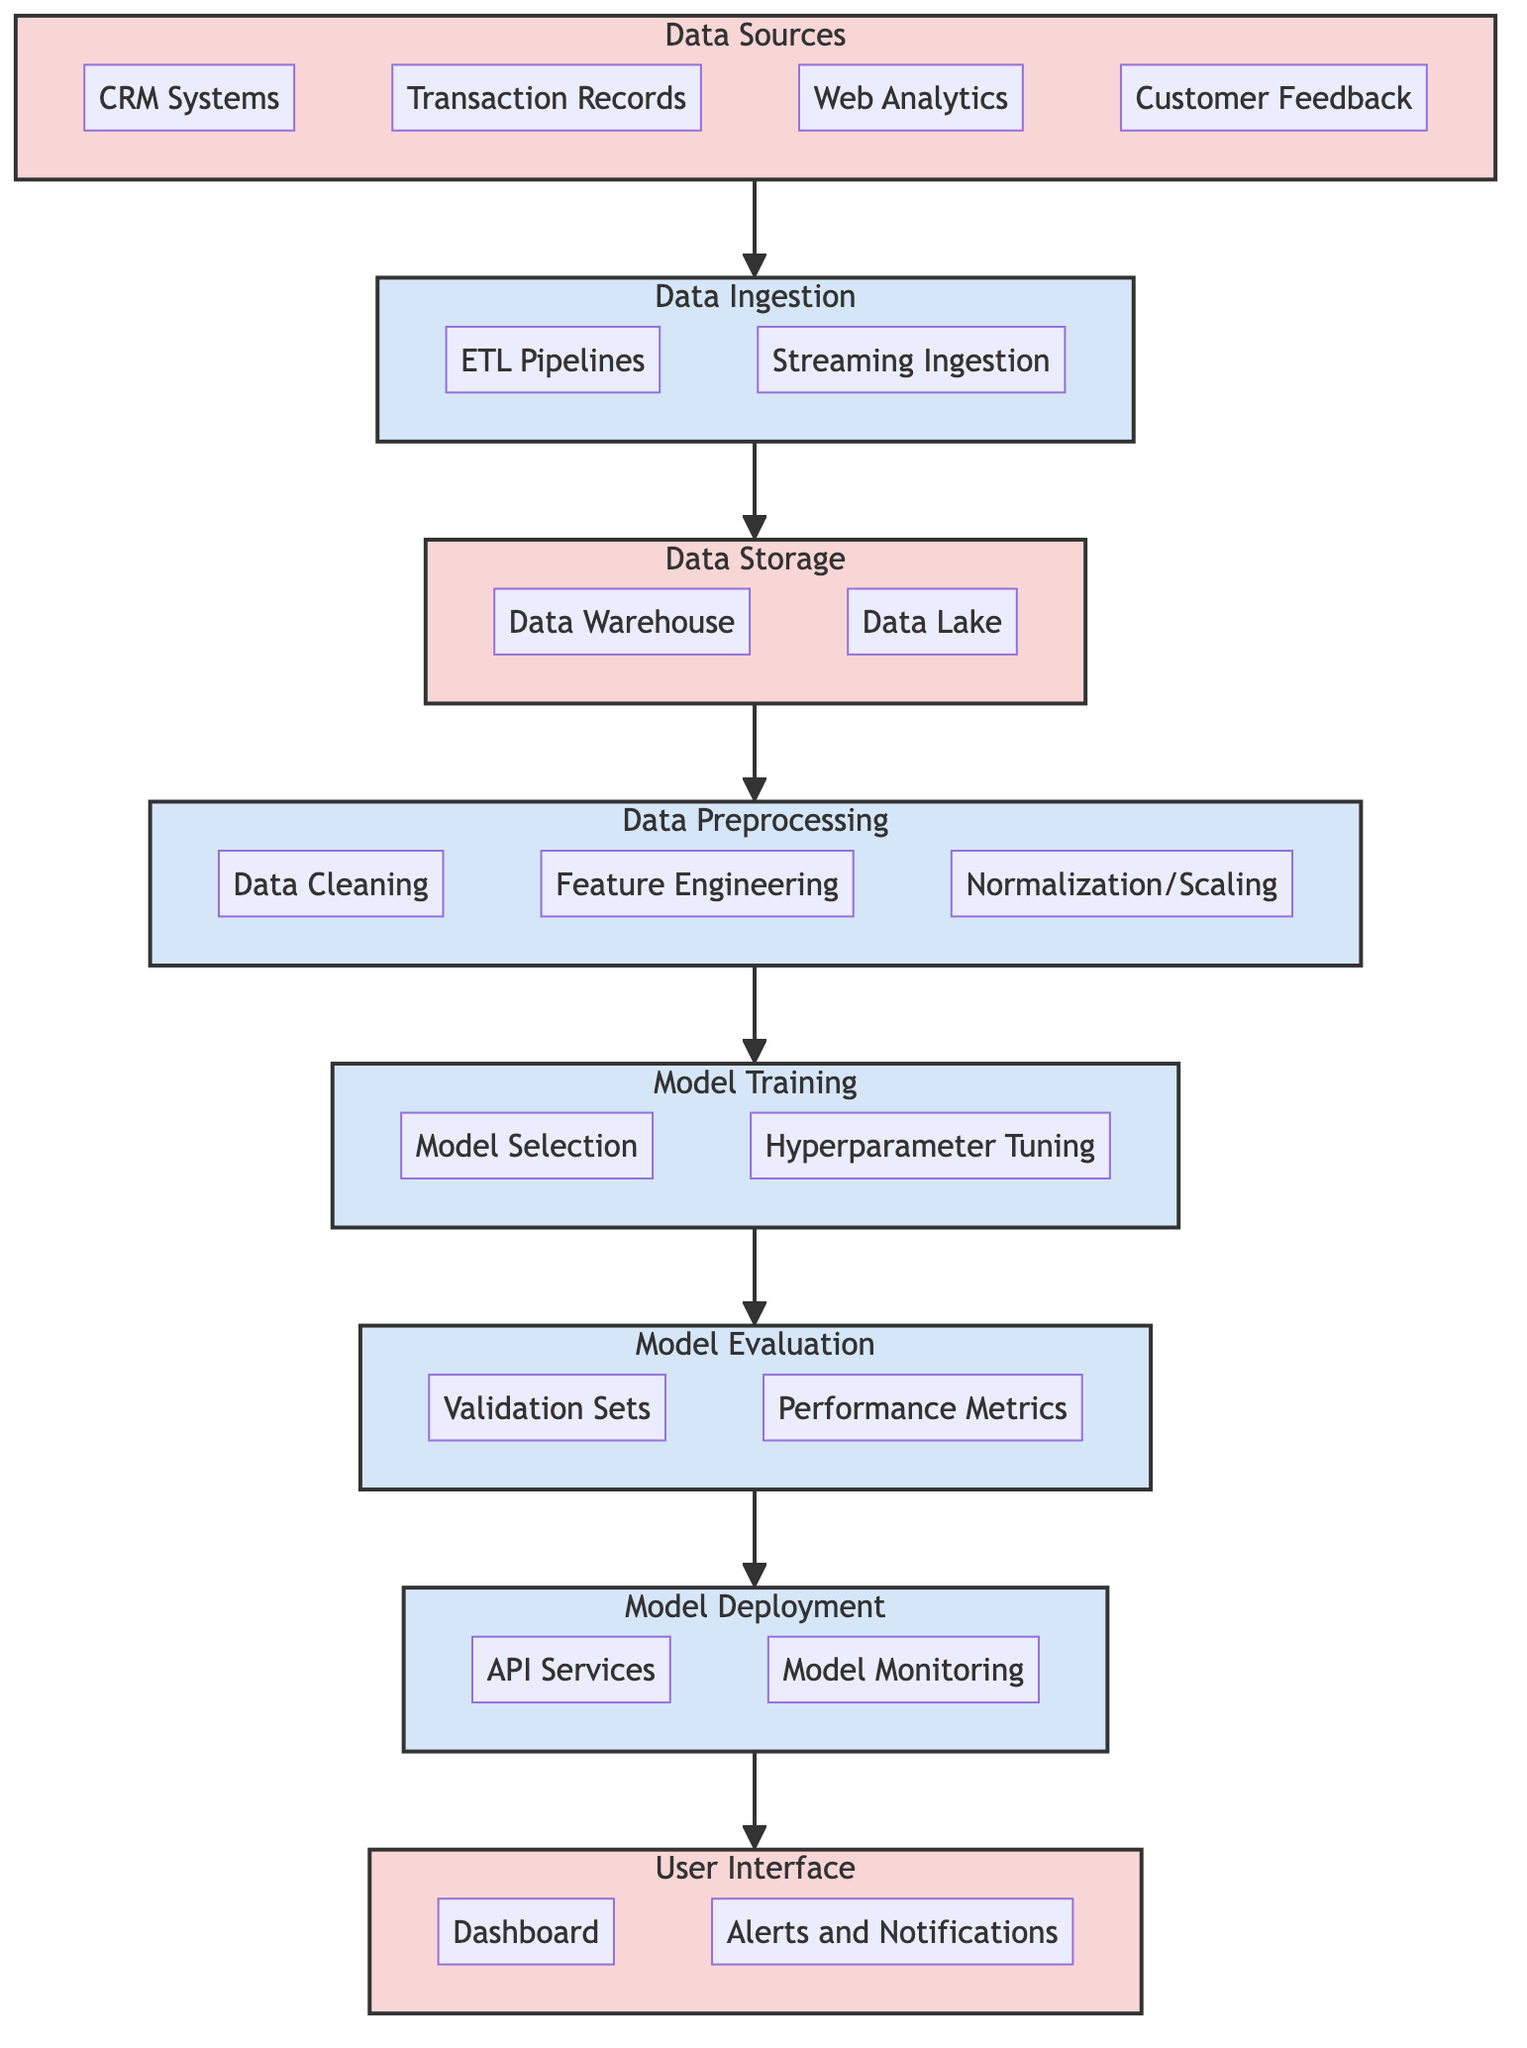What are the components in the User Interface? The diagram shows two components within the User Interface subgraph: the Dashboard and Alerts and Notifications.
Answer: Dashboard, Alerts and Notifications How many nodes are there in the Model Training process? In the Model Training process subgraph, there are two nodes: Model Selection and Hyperparameter Tuning, making a total of two nodes.
Answer: 2 What is the purpose of Data Ingestion in this model? The Data Ingestion process involves collecting and ingesting data into a storage solution, specifically using ETL Pipelines and Streaming Ingestion.
Answer: Collect data What is the relationship between Model Evaluation and Model Deployment? Model Evaluation directly feeds into Model Deployment. After evaluating the model's performance, the next step is to deploy the model into production.
Answer: Directly feeds into What are the subcomponents of Data Sources? The Data Sources component has four subcomponents: CRM Systems, Transaction Records, Web Analytics, and Customer Feedback.
Answer: CRM Systems, Transaction Records, Web Analytics, Customer Feedback What do the arrows in the diagram represent? The arrows indicate the flow of the process, showing the sequence of steps from Data Sources through to Model Deployment and finally to the User Interface.
Answer: Sequence of steps Which processes occur before Model Deployment? Before Model Deployment, the process sequence goes through Model Evaluation, Model Training, and Data Preprocessing.
Answer: Model Evaluation, Model Training, Data Preprocessing What metrics are included in Model Evaluation? The Model Evaluation process includes two metrics: Validation Sets and Performance Metrics.
Answer: Validation Sets, Performance Metrics How is the data stored after ingestion? After data ingestion, it is stored in either a Data Warehouse or a Data Lake, depending on the type of data and storage needs.
Answer: Data Warehouse, Data Lake 